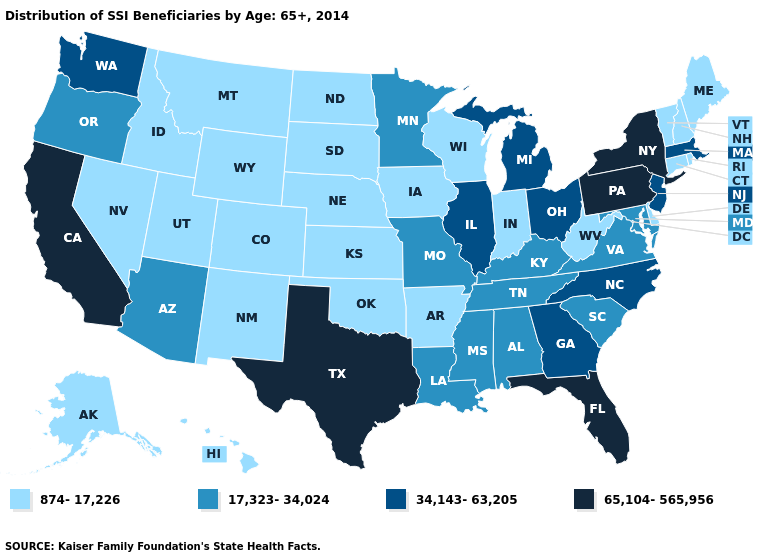Which states have the lowest value in the USA?
Quick response, please. Alaska, Arkansas, Colorado, Connecticut, Delaware, Hawaii, Idaho, Indiana, Iowa, Kansas, Maine, Montana, Nebraska, Nevada, New Hampshire, New Mexico, North Dakota, Oklahoma, Rhode Island, South Dakota, Utah, Vermont, West Virginia, Wisconsin, Wyoming. Does Washington have the highest value in the West?
Be succinct. No. Which states have the highest value in the USA?
Keep it brief. California, Florida, New York, Pennsylvania, Texas. What is the lowest value in states that border Wisconsin?
Short answer required. 874-17,226. Does the map have missing data?
Short answer required. No. Does North Carolina have a lower value than Florida?
Answer briefly. Yes. Among the states that border Pennsylvania , which have the highest value?
Answer briefly. New York. Name the states that have a value in the range 17,323-34,024?
Answer briefly. Alabama, Arizona, Kentucky, Louisiana, Maryland, Minnesota, Mississippi, Missouri, Oregon, South Carolina, Tennessee, Virginia. Does Georgia have the lowest value in the USA?
Keep it brief. No. Is the legend a continuous bar?
Short answer required. No. What is the value of New York?
Quick response, please. 65,104-565,956. What is the value of New York?
Concise answer only. 65,104-565,956. Among the states that border New Mexico , which have the lowest value?
Write a very short answer. Colorado, Oklahoma, Utah. What is the value of Washington?
Answer briefly. 34,143-63,205. Among the states that border Alabama , does Mississippi have the lowest value?
Be succinct. Yes. 